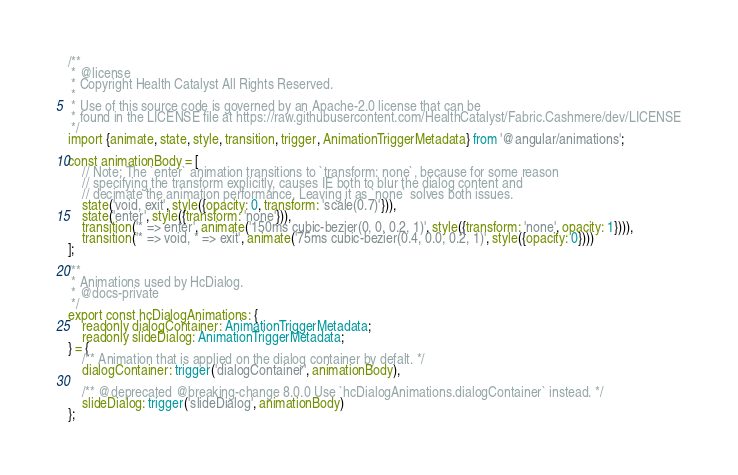Convert code to text. <code><loc_0><loc_0><loc_500><loc_500><_TypeScript_>/**
 * @license
 * Copyright Health Catalyst All Rights Reserved.
 *
 * Use of this source code is governed by an Apache-2.0 license that can be
 * found in the LICENSE file at https://raw.githubusercontent.com/HealthCatalyst/Fabric.Cashmere/dev/LICENSE
 */
import {animate, state, style, transition, trigger, AnimationTriggerMetadata} from '@angular/animations';

const animationBody = [
    // Note: The `enter` animation transitions to `transform: none`, because for some reason
    // specifying the transform explicitly, causes IE both to blur the dialog content and
    // decimate the animation performance. Leaving it as `none` solves both issues.
    state('void, exit', style({opacity: 0, transform: 'scale(0.7)'})),
    state('enter', style({transform: 'none'})),
    transition('* => enter', animate('150ms cubic-bezier(0, 0, 0.2, 1)', style({transform: 'none', opacity: 1}))),
    transition('* => void, * => exit', animate('75ms cubic-bezier(0.4, 0.0, 0.2, 1)', style({opacity: 0})))
];

/**
 * Animations used by HcDialog.
 * @docs-private
 */
export const hcDialogAnimations: {
    readonly dialogContainer: AnimationTriggerMetadata;
    readonly slideDialog: AnimationTriggerMetadata;
} = {
    /** Animation that is applied on the dialog container by defalt. */
    dialogContainer: trigger('dialogContainer', animationBody),

    /** @deprecated @breaking-change 8.0.0 Use `hcDialogAnimations.dialogContainer` instead. */
    slideDialog: trigger('slideDialog', animationBody)
};
</code> 